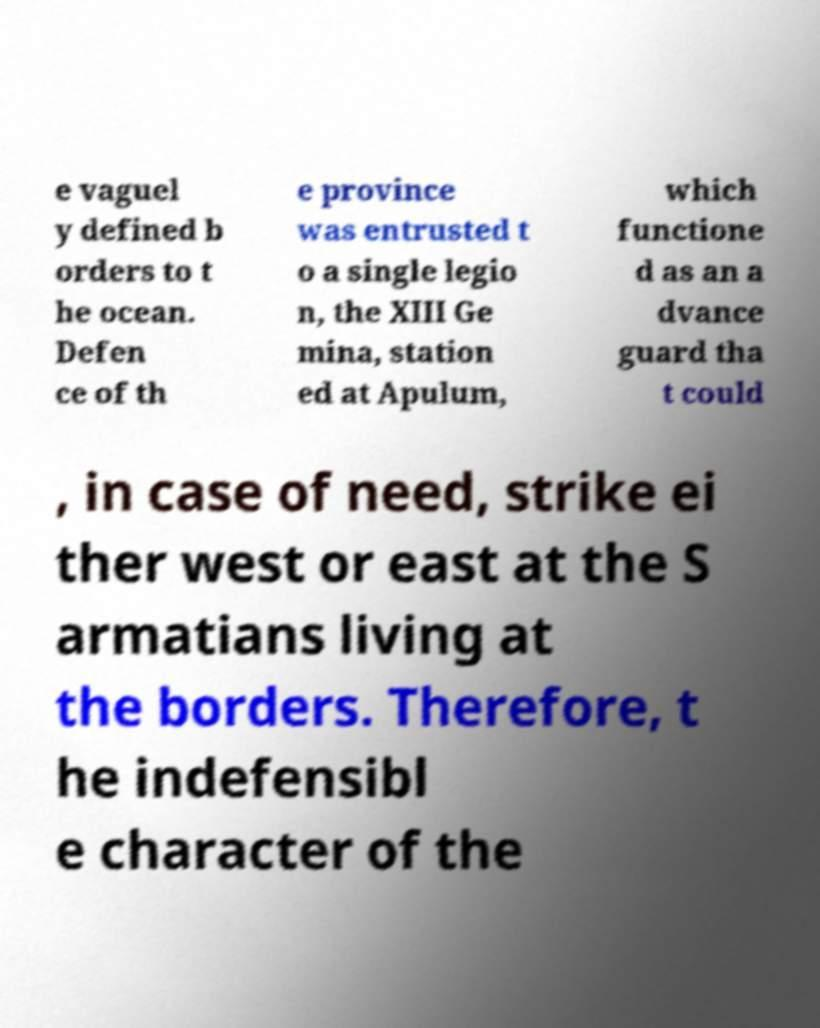Can you accurately transcribe the text from the provided image for me? e vaguel y defined b orders to t he ocean. Defen ce of th e province was entrusted t o a single legio n, the XIII Ge mina, station ed at Apulum, which functione d as an a dvance guard tha t could , in case of need, strike ei ther west or east at the S armatians living at the borders. Therefore, t he indefensibl e character of the 